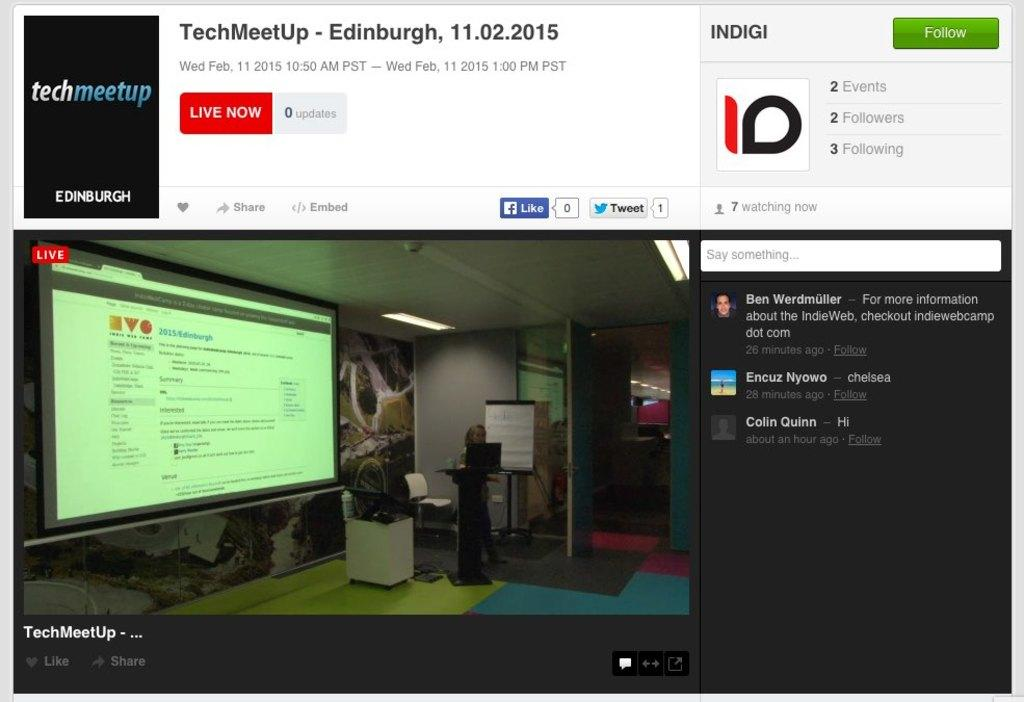<image>
Share a concise interpretation of the image provided. A website page with a live tech meet up in Edinburgh. 